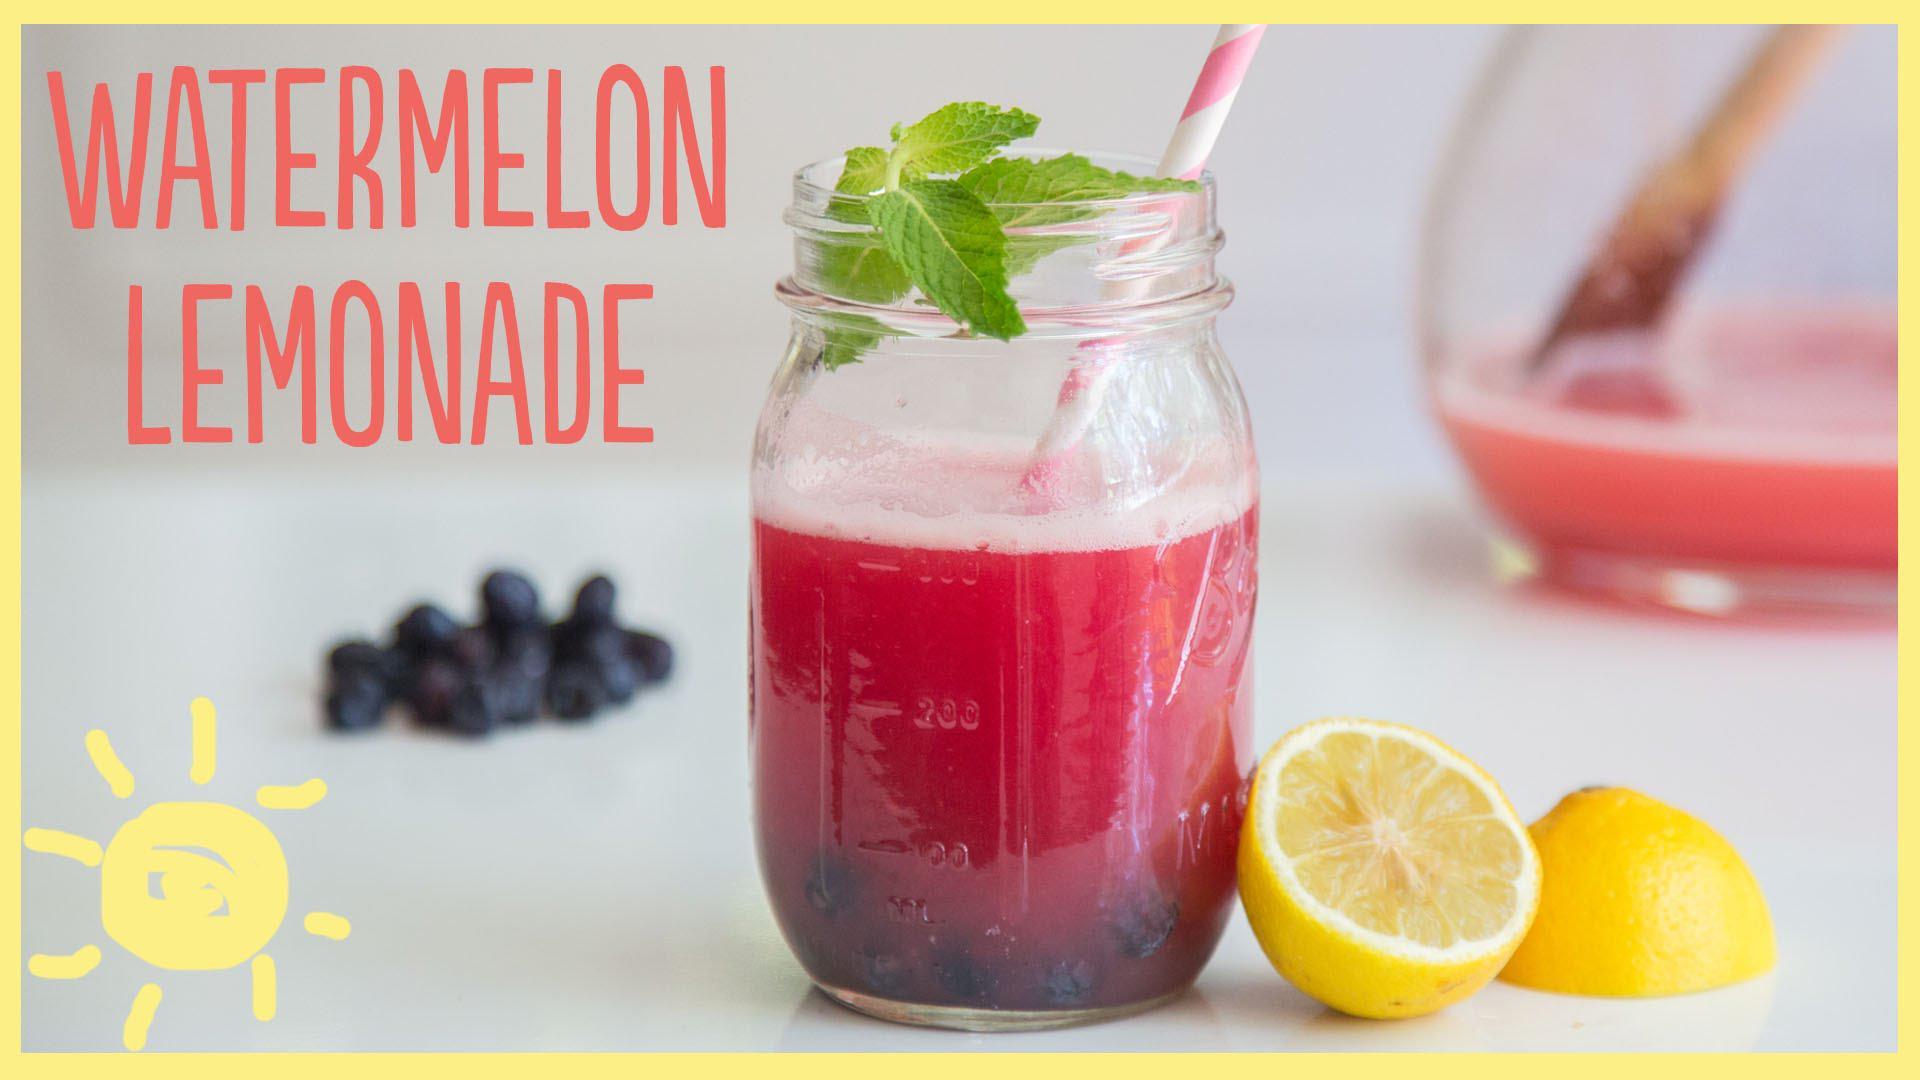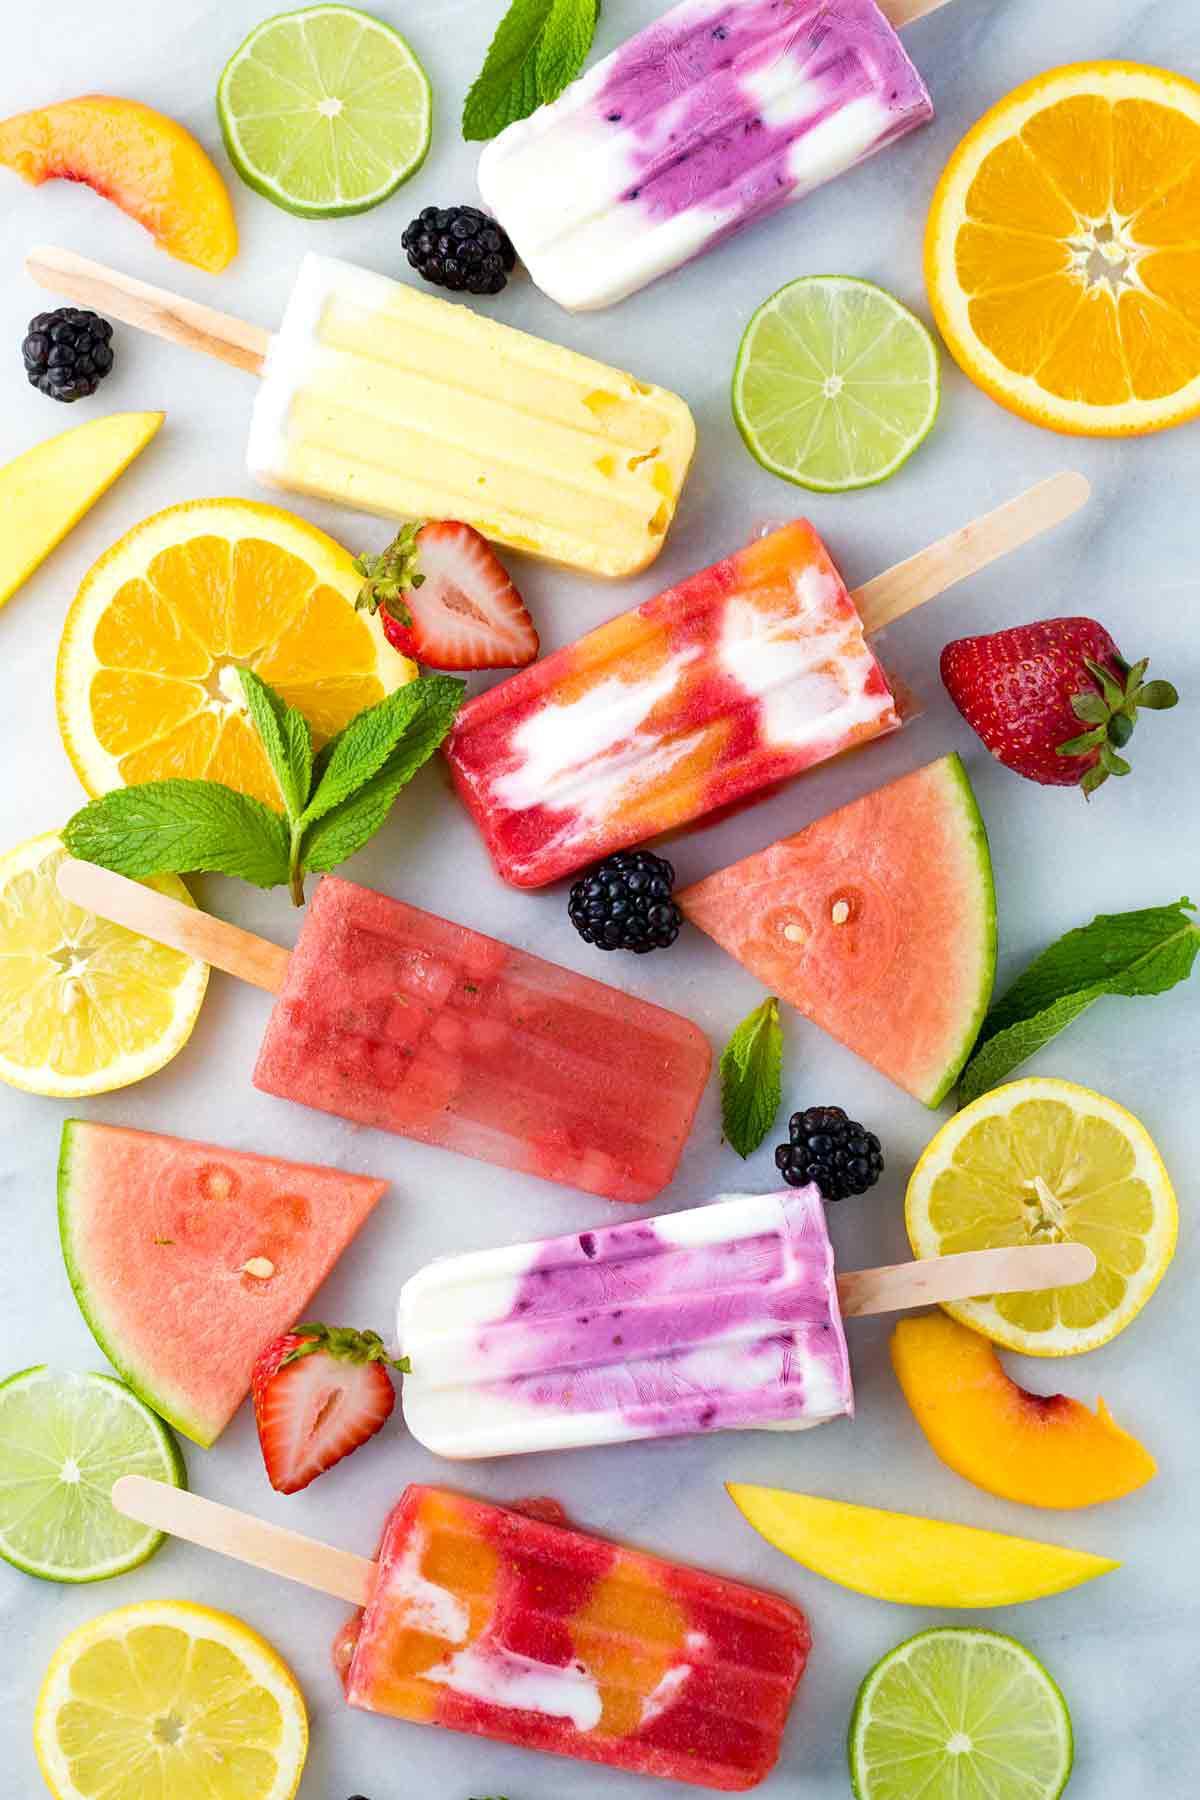The first image is the image on the left, the second image is the image on the right. Analyze the images presented: Is the assertion "There is a straw with pink swirl in a drink." valid? Answer yes or no. Yes. The first image is the image on the left, the second image is the image on the right. Assess this claim about the two images: "In one image, a red drink in a canning jar has at least one straw.". Correct or not? Answer yes or no. Yes. 